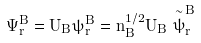Convert formula to latex. <formula><loc_0><loc_0><loc_500><loc_500>\Psi _ { r } ^ { B } = U _ { B } \psi _ { r } ^ { B } = n _ { B } ^ { 1 / 2 } U _ { B } \stackrel { \sim } { \psi } _ { r } ^ { B }</formula> 